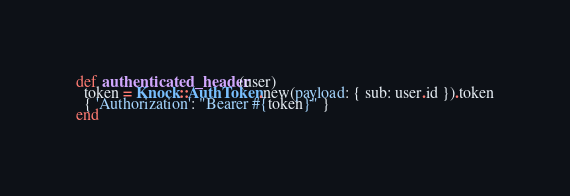Convert code to text. <code><loc_0><loc_0><loc_500><loc_500><_Ruby_>def authenticated_header(user)
  token = Knock::AuthToken.new(payload: { sub: user.id }).token
  { 'Authorization': "Bearer #{token}" }
end</code> 